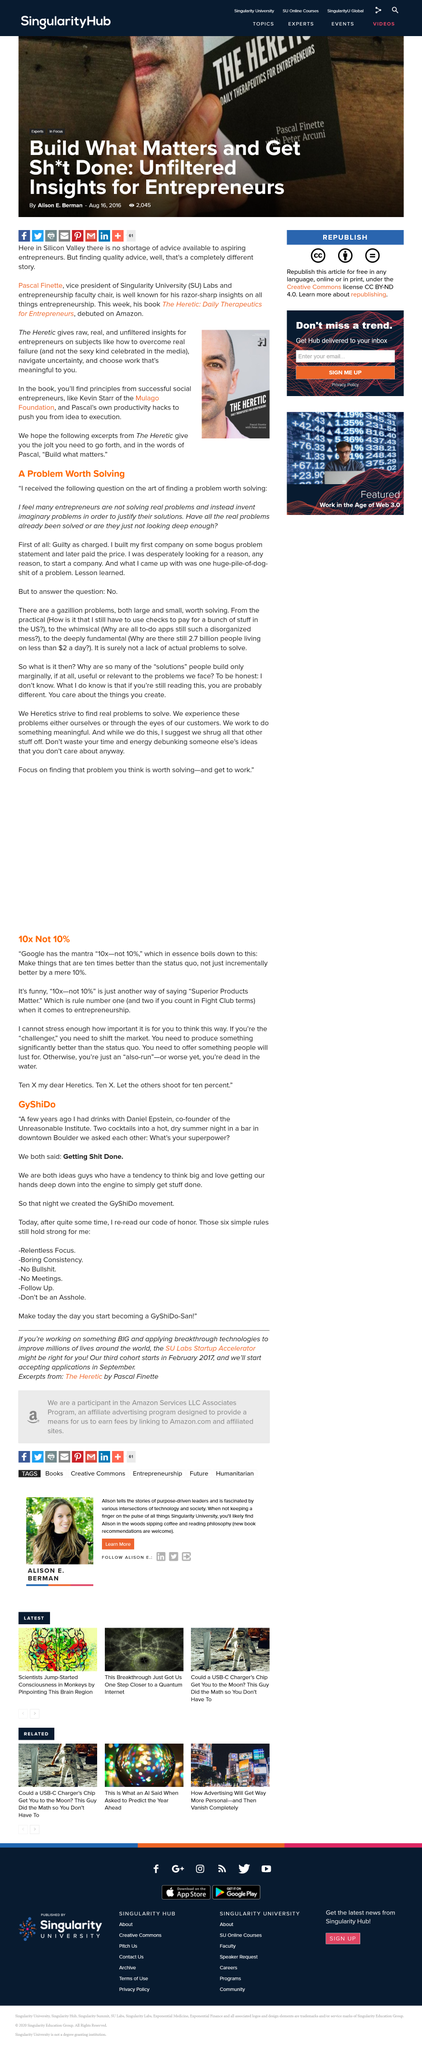List a handful of essential elements in this visual. Google's mantra "10x--not 10%" means that we strive to create innovative and significantly improved products and services, not just incrementally better versions of existing ones by a mere 10%. This article focuses on a problem worth solving. As of today, an estimated 2.7 billion people are still surviving on less than $2 a day. As the challenger, the key to shifting the market is to offer a product or service that is significantly superior to what currently exists. Pascal Finette is the author of "The Heretic. 